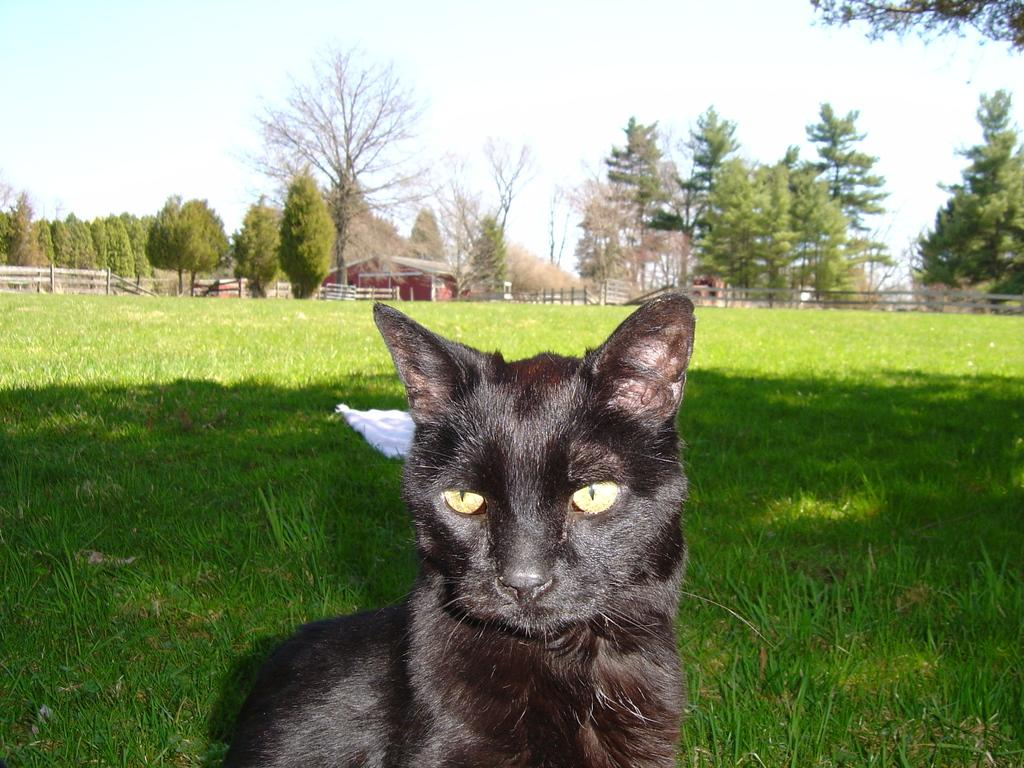What animal is in the foreground of the image? There is a black cat in the foreground of the image. What type of vegetation is in the center of the image? There is grass in the center of the image. What can be seen in the background of the image? There are trees and a house in the background of the image, along with fencing. Can you see the maid smiling in the image? There is no maid or smiling person present in the image. 